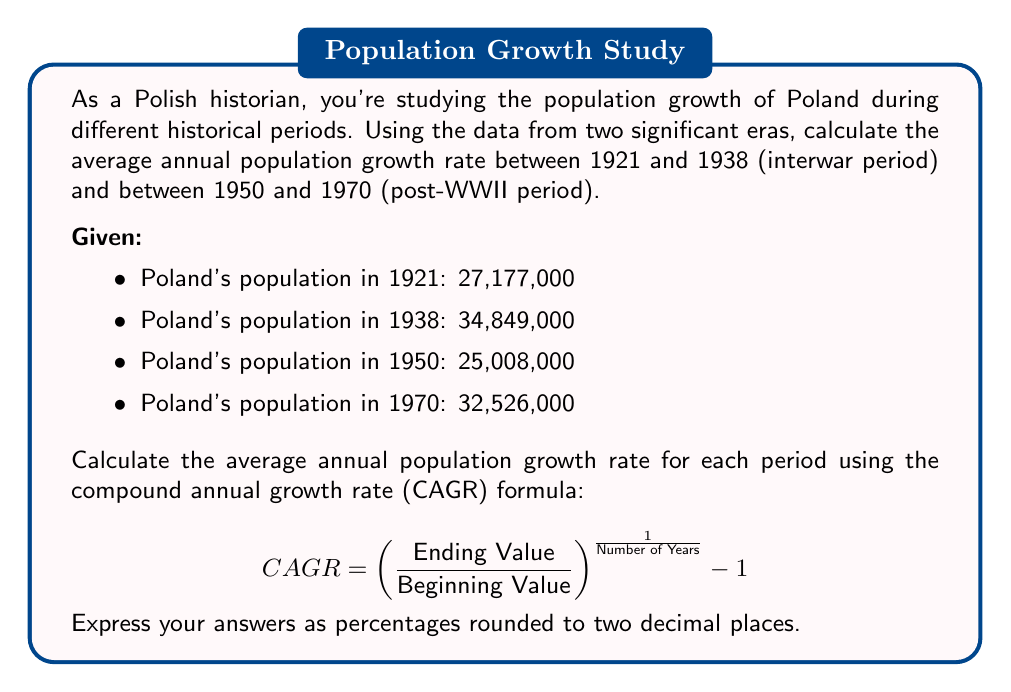Show me your answer to this math problem. To solve this problem, we'll use the CAGR formula for each period:

1. Interwar period (1921-1938):

$$ CAGR_{1921-1938} = \left(\frac{34,849,000}{27,177,000}\right)^{\frac{1}{1938-1921}} - 1 $$

$$ = \left(\frac{34,849,000}{27,177,000}\right)^{\frac{1}{17}} - 1 $$

$$ = (1.282)^{\frac{1}{17}} - 1 $$

$$ = 1.0147 - 1 = 0.0147 $$

$$ = 1.47\% $$

2. Post-WWII period (1950-1970):

$$ CAGR_{1950-1970} = \left(\frac{32,526,000}{25,008,000}\right)^{\frac{1}{1970-1950}} - 1 $$

$$ = \left(\frac{32,526,000}{25,008,000}\right)^{\frac{1}{20}} - 1 $$

$$ = (1.300)^{\frac{1}{20}} - 1 $$

$$ = 1.0133 - 1 = 0.0133 $$

$$ = 1.33\% $$

The average annual population growth rates for the two periods are 1.47% and 1.33%, respectively.
Answer: The average annual population growth rate for Poland was 1.47% during the interwar period (1921-1938) and 1.33% during the post-WWII period (1950-1970). 